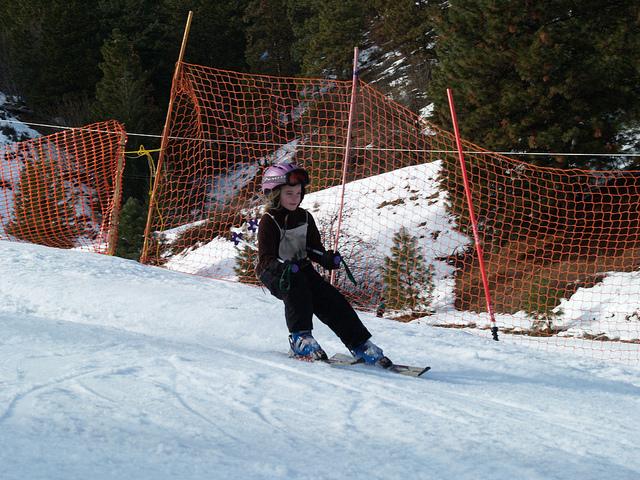What does the fence appear to be made out of?
Write a very short answer. Plastic. What color are the skier's boots?
Answer briefly. Blue. Is the kid a good skier?
Answer briefly. Yes. 